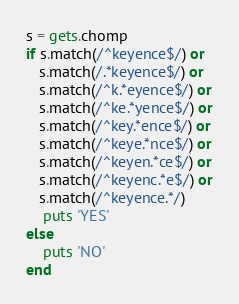Convert code to text. <code><loc_0><loc_0><loc_500><loc_500><_Ruby_>s = gets.chomp
if s.match(/^keyence$/) or
   s.match(/.*keyence$/) or
   s.match(/^k.*eyence$/) or
   s.match(/^ke.*yence$/) or
   s.match(/^key.*ence$/) or
   s.match(/^keye.*nce$/) or
   s.match(/^keyen.*ce$/) or
   s.match(/^keyenc.*e$/) or
   s.match(/^keyence.*/)
    puts 'YES'
else
    puts 'NO'
end</code> 